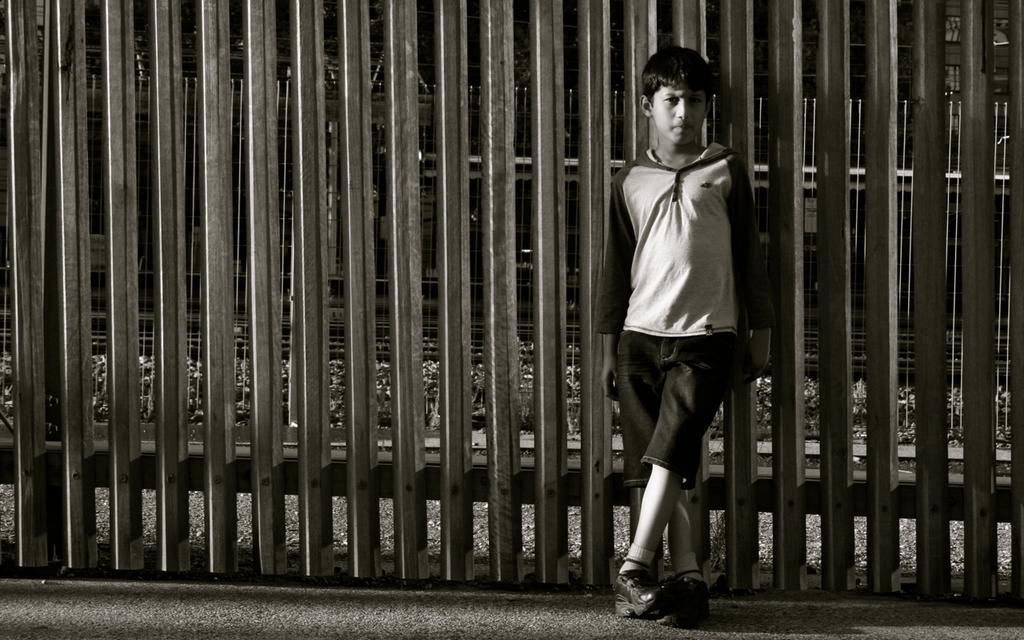Who is the main subject in the image? There is a boy in the image. What is the boy wearing? The boy is wearing a jacket and shorts. What is the boy's posture in the image? The boy is standing. What can be seen in the background of the image? There is a fencing behind the boy. What type of finger can be seen holding a wrench in the image? There is no finger or wrench present in the image; it features a boy wearing a jacket and shorts, standing in front of a fencing. 